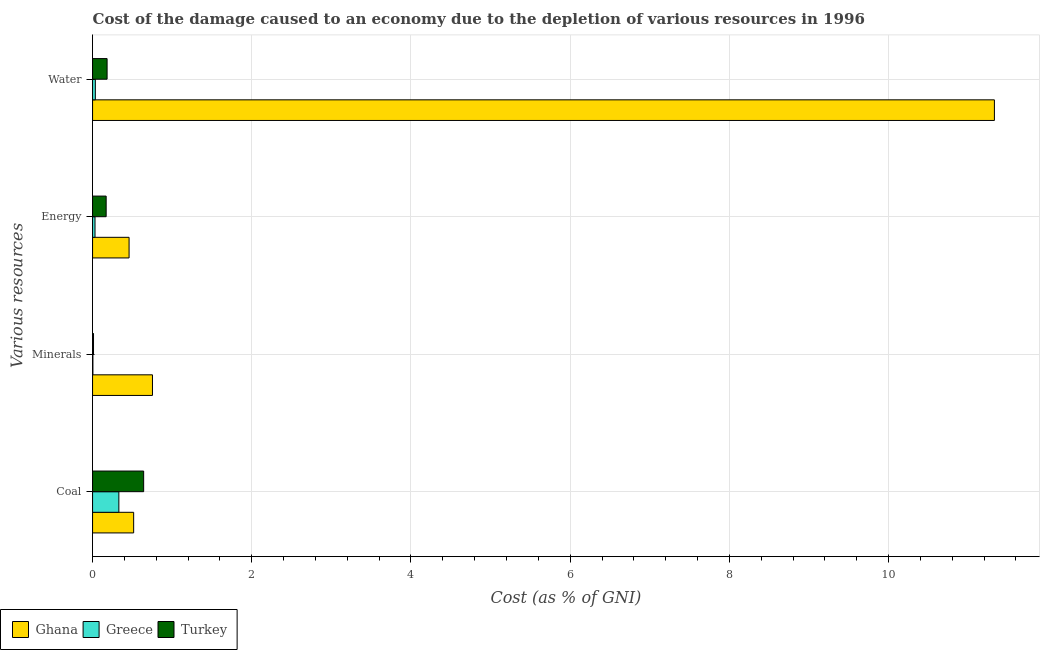Are the number of bars per tick equal to the number of legend labels?
Your answer should be very brief. Yes. How many bars are there on the 1st tick from the top?
Ensure brevity in your answer.  3. How many bars are there on the 4th tick from the bottom?
Provide a short and direct response. 3. What is the label of the 2nd group of bars from the top?
Provide a short and direct response. Energy. What is the cost of damage due to depletion of minerals in Greece?
Make the answer very short. 0. Across all countries, what is the maximum cost of damage due to depletion of water?
Keep it short and to the point. 11.33. Across all countries, what is the minimum cost of damage due to depletion of water?
Provide a short and direct response. 0.03. In which country was the cost of damage due to depletion of water maximum?
Ensure brevity in your answer.  Ghana. What is the total cost of damage due to depletion of water in the graph?
Keep it short and to the point. 11.55. What is the difference between the cost of damage due to depletion of water in Ghana and that in Greece?
Offer a very short reply. 11.29. What is the difference between the cost of damage due to depletion of water in Turkey and the cost of damage due to depletion of energy in Ghana?
Provide a succinct answer. -0.28. What is the average cost of damage due to depletion of water per country?
Offer a very short reply. 3.85. What is the difference between the cost of damage due to depletion of coal and cost of damage due to depletion of minerals in Greece?
Provide a succinct answer. 0.33. What is the ratio of the cost of damage due to depletion of energy in Ghana to that in Greece?
Provide a succinct answer. 14.93. Is the difference between the cost of damage due to depletion of minerals in Greece and Turkey greater than the difference between the cost of damage due to depletion of water in Greece and Turkey?
Keep it short and to the point. Yes. What is the difference between the highest and the second highest cost of damage due to depletion of water?
Give a very brief answer. 11.15. What is the difference between the highest and the lowest cost of damage due to depletion of coal?
Your answer should be very brief. 0.31. In how many countries, is the cost of damage due to depletion of coal greater than the average cost of damage due to depletion of coal taken over all countries?
Make the answer very short. 2. Is the sum of the cost of damage due to depletion of water in Greece and Ghana greater than the maximum cost of damage due to depletion of energy across all countries?
Give a very brief answer. Yes. Is it the case that in every country, the sum of the cost of damage due to depletion of coal and cost of damage due to depletion of minerals is greater than the sum of cost of damage due to depletion of water and cost of damage due to depletion of energy?
Give a very brief answer. Yes. How many bars are there?
Provide a succinct answer. 12. Are all the bars in the graph horizontal?
Offer a very short reply. Yes. What is the difference between two consecutive major ticks on the X-axis?
Offer a terse response. 2. Are the values on the major ticks of X-axis written in scientific E-notation?
Provide a short and direct response. No. Does the graph contain any zero values?
Make the answer very short. No. Does the graph contain grids?
Provide a succinct answer. Yes. Where does the legend appear in the graph?
Offer a terse response. Bottom left. How many legend labels are there?
Give a very brief answer. 3. How are the legend labels stacked?
Provide a succinct answer. Horizontal. What is the title of the graph?
Your answer should be compact. Cost of the damage caused to an economy due to the depletion of various resources in 1996 . What is the label or title of the X-axis?
Provide a succinct answer. Cost (as % of GNI). What is the label or title of the Y-axis?
Offer a very short reply. Various resources. What is the Cost (as % of GNI) of Ghana in Coal?
Provide a succinct answer. 0.52. What is the Cost (as % of GNI) of Greece in Coal?
Provide a short and direct response. 0.33. What is the Cost (as % of GNI) of Turkey in Coal?
Ensure brevity in your answer.  0.64. What is the Cost (as % of GNI) in Ghana in Minerals?
Ensure brevity in your answer.  0.75. What is the Cost (as % of GNI) in Greece in Minerals?
Keep it short and to the point. 0. What is the Cost (as % of GNI) in Turkey in Minerals?
Provide a short and direct response. 0.01. What is the Cost (as % of GNI) of Ghana in Energy?
Make the answer very short. 0.46. What is the Cost (as % of GNI) in Greece in Energy?
Ensure brevity in your answer.  0.03. What is the Cost (as % of GNI) of Turkey in Energy?
Ensure brevity in your answer.  0.17. What is the Cost (as % of GNI) of Ghana in Water?
Offer a terse response. 11.33. What is the Cost (as % of GNI) in Greece in Water?
Offer a very short reply. 0.03. What is the Cost (as % of GNI) of Turkey in Water?
Provide a short and direct response. 0.18. Across all Various resources, what is the maximum Cost (as % of GNI) in Ghana?
Your answer should be very brief. 11.33. Across all Various resources, what is the maximum Cost (as % of GNI) in Greece?
Your response must be concise. 0.33. Across all Various resources, what is the maximum Cost (as % of GNI) of Turkey?
Ensure brevity in your answer.  0.64. Across all Various resources, what is the minimum Cost (as % of GNI) in Ghana?
Your answer should be compact. 0.46. Across all Various resources, what is the minimum Cost (as % of GNI) of Greece?
Offer a terse response. 0. Across all Various resources, what is the minimum Cost (as % of GNI) of Turkey?
Provide a short and direct response. 0.01. What is the total Cost (as % of GNI) of Ghana in the graph?
Provide a succinct answer. 13.06. What is the total Cost (as % of GNI) in Greece in the graph?
Provide a succinct answer. 0.4. What is the difference between the Cost (as % of GNI) of Ghana in Coal and that in Minerals?
Make the answer very short. -0.24. What is the difference between the Cost (as % of GNI) in Greece in Coal and that in Minerals?
Offer a terse response. 0.33. What is the difference between the Cost (as % of GNI) of Turkey in Coal and that in Minerals?
Ensure brevity in your answer.  0.63. What is the difference between the Cost (as % of GNI) in Ghana in Coal and that in Energy?
Give a very brief answer. 0.06. What is the difference between the Cost (as % of GNI) in Greece in Coal and that in Energy?
Provide a short and direct response. 0.3. What is the difference between the Cost (as % of GNI) of Turkey in Coal and that in Energy?
Your answer should be very brief. 0.47. What is the difference between the Cost (as % of GNI) in Ghana in Coal and that in Water?
Keep it short and to the point. -10.81. What is the difference between the Cost (as % of GNI) of Greece in Coal and that in Water?
Provide a short and direct response. 0.3. What is the difference between the Cost (as % of GNI) of Turkey in Coal and that in Water?
Give a very brief answer. 0.46. What is the difference between the Cost (as % of GNI) in Ghana in Minerals and that in Energy?
Your response must be concise. 0.29. What is the difference between the Cost (as % of GNI) of Greece in Minerals and that in Energy?
Your answer should be very brief. -0.03. What is the difference between the Cost (as % of GNI) of Turkey in Minerals and that in Energy?
Give a very brief answer. -0.16. What is the difference between the Cost (as % of GNI) of Ghana in Minerals and that in Water?
Your response must be concise. -10.58. What is the difference between the Cost (as % of GNI) in Greece in Minerals and that in Water?
Your response must be concise. -0.03. What is the difference between the Cost (as % of GNI) in Turkey in Minerals and that in Water?
Your answer should be compact. -0.17. What is the difference between the Cost (as % of GNI) in Ghana in Energy and that in Water?
Provide a succinct answer. -10.87. What is the difference between the Cost (as % of GNI) of Greece in Energy and that in Water?
Offer a very short reply. -0. What is the difference between the Cost (as % of GNI) in Turkey in Energy and that in Water?
Provide a short and direct response. -0.01. What is the difference between the Cost (as % of GNI) in Ghana in Coal and the Cost (as % of GNI) in Greece in Minerals?
Offer a very short reply. 0.51. What is the difference between the Cost (as % of GNI) in Ghana in Coal and the Cost (as % of GNI) in Turkey in Minerals?
Provide a short and direct response. 0.5. What is the difference between the Cost (as % of GNI) in Greece in Coal and the Cost (as % of GNI) in Turkey in Minerals?
Provide a short and direct response. 0.32. What is the difference between the Cost (as % of GNI) in Ghana in Coal and the Cost (as % of GNI) in Greece in Energy?
Offer a very short reply. 0.49. What is the difference between the Cost (as % of GNI) of Ghana in Coal and the Cost (as % of GNI) of Turkey in Energy?
Offer a terse response. 0.35. What is the difference between the Cost (as % of GNI) in Greece in Coal and the Cost (as % of GNI) in Turkey in Energy?
Offer a very short reply. 0.16. What is the difference between the Cost (as % of GNI) of Ghana in Coal and the Cost (as % of GNI) of Greece in Water?
Your answer should be very brief. 0.48. What is the difference between the Cost (as % of GNI) of Ghana in Coal and the Cost (as % of GNI) of Turkey in Water?
Keep it short and to the point. 0.33. What is the difference between the Cost (as % of GNI) in Greece in Coal and the Cost (as % of GNI) in Turkey in Water?
Give a very brief answer. 0.15. What is the difference between the Cost (as % of GNI) in Ghana in Minerals and the Cost (as % of GNI) in Greece in Energy?
Ensure brevity in your answer.  0.72. What is the difference between the Cost (as % of GNI) of Ghana in Minerals and the Cost (as % of GNI) of Turkey in Energy?
Provide a short and direct response. 0.58. What is the difference between the Cost (as % of GNI) in Greece in Minerals and the Cost (as % of GNI) in Turkey in Energy?
Provide a short and direct response. -0.17. What is the difference between the Cost (as % of GNI) in Ghana in Minerals and the Cost (as % of GNI) in Greece in Water?
Offer a very short reply. 0.72. What is the difference between the Cost (as % of GNI) in Ghana in Minerals and the Cost (as % of GNI) in Turkey in Water?
Your response must be concise. 0.57. What is the difference between the Cost (as % of GNI) of Greece in Minerals and the Cost (as % of GNI) of Turkey in Water?
Your answer should be compact. -0.18. What is the difference between the Cost (as % of GNI) of Ghana in Energy and the Cost (as % of GNI) of Greece in Water?
Offer a terse response. 0.42. What is the difference between the Cost (as % of GNI) in Ghana in Energy and the Cost (as % of GNI) in Turkey in Water?
Make the answer very short. 0.28. What is the difference between the Cost (as % of GNI) in Greece in Energy and the Cost (as % of GNI) in Turkey in Water?
Provide a succinct answer. -0.15. What is the average Cost (as % of GNI) in Ghana per Various resources?
Offer a terse response. 3.26. What is the average Cost (as % of GNI) of Greece per Various resources?
Offer a very short reply. 0.1. What is the average Cost (as % of GNI) of Turkey per Various resources?
Provide a short and direct response. 0.25. What is the difference between the Cost (as % of GNI) of Ghana and Cost (as % of GNI) of Greece in Coal?
Your answer should be very brief. 0.19. What is the difference between the Cost (as % of GNI) in Ghana and Cost (as % of GNI) in Turkey in Coal?
Offer a very short reply. -0.13. What is the difference between the Cost (as % of GNI) of Greece and Cost (as % of GNI) of Turkey in Coal?
Your answer should be very brief. -0.31. What is the difference between the Cost (as % of GNI) of Ghana and Cost (as % of GNI) of Greece in Minerals?
Offer a terse response. 0.75. What is the difference between the Cost (as % of GNI) of Ghana and Cost (as % of GNI) of Turkey in Minerals?
Your response must be concise. 0.74. What is the difference between the Cost (as % of GNI) of Greece and Cost (as % of GNI) of Turkey in Minerals?
Offer a terse response. -0.01. What is the difference between the Cost (as % of GNI) of Ghana and Cost (as % of GNI) of Greece in Energy?
Provide a short and direct response. 0.43. What is the difference between the Cost (as % of GNI) of Ghana and Cost (as % of GNI) of Turkey in Energy?
Your answer should be very brief. 0.29. What is the difference between the Cost (as % of GNI) in Greece and Cost (as % of GNI) in Turkey in Energy?
Keep it short and to the point. -0.14. What is the difference between the Cost (as % of GNI) in Ghana and Cost (as % of GNI) in Greece in Water?
Offer a terse response. 11.29. What is the difference between the Cost (as % of GNI) of Ghana and Cost (as % of GNI) of Turkey in Water?
Give a very brief answer. 11.15. What is the difference between the Cost (as % of GNI) in Greece and Cost (as % of GNI) in Turkey in Water?
Offer a very short reply. -0.15. What is the ratio of the Cost (as % of GNI) of Ghana in Coal to that in Minerals?
Ensure brevity in your answer.  0.69. What is the ratio of the Cost (as % of GNI) in Greece in Coal to that in Minerals?
Ensure brevity in your answer.  78.85. What is the ratio of the Cost (as % of GNI) of Turkey in Coal to that in Minerals?
Offer a terse response. 54.26. What is the ratio of the Cost (as % of GNI) of Ghana in Coal to that in Energy?
Your answer should be very brief. 1.13. What is the ratio of the Cost (as % of GNI) in Greece in Coal to that in Energy?
Your answer should be very brief. 10.76. What is the ratio of the Cost (as % of GNI) of Turkey in Coal to that in Energy?
Give a very brief answer. 3.76. What is the ratio of the Cost (as % of GNI) of Ghana in Coal to that in Water?
Your answer should be compact. 0.05. What is the ratio of the Cost (as % of GNI) of Greece in Coal to that in Water?
Your answer should be very brief. 9.47. What is the ratio of the Cost (as % of GNI) of Turkey in Coal to that in Water?
Offer a very short reply. 3.52. What is the ratio of the Cost (as % of GNI) of Ghana in Minerals to that in Energy?
Provide a short and direct response. 1.64. What is the ratio of the Cost (as % of GNI) in Greece in Minerals to that in Energy?
Provide a short and direct response. 0.14. What is the ratio of the Cost (as % of GNI) of Turkey in Minerals to that in Energy?
Your answer should be compact. 0.07. What is the ratio of the Cost (as % of GNI) in Ghana in Minerals to that in Water?
Keep it short and to the point. 0.07. What is the ratio of the Cost (as % of GNI) in Greece in Minerals to that in Water?
Provide a succinct answer. 0.12. What is the ratio of the Cost (as % of GNI) of Turkey in Minerals to that in Water?
Your response must be concise. 0.06. What is the ratio of the Cost (as % of GNI) in Ghana in Energy to that in Water?
Offer a terse response. 0.04. What is the ratio of the Cost (as % of GNI) in Turkey in Energy to that in Water?
Your answer should be compact. 0.94. What is the difference between the highest and the second highest Cost (as % of GNI) of Ghana?
Your answer should be very brief. 10.58. What is the difference between the highest and the second highest Cost (as % of GNI) in Greece?
Your response must be concise. 0.3. What is the difference between the highest and the second highest Cost (as % of GNI) of Turkey?
Keep it short and to the point. 0.46. What is the difference between the highest and the lowest Cost (as % of GNI) of Ghana?
Provide a short and direct response. 10.87. What is the difference between the highest and the lowest Cost (as % of GNI) in Greece?
Keep it short and to the point. 0.33. What is the difference between the highest and the lowest Cost (as % of GNI) in Turkey?
Offer a terse response. 0.63. 